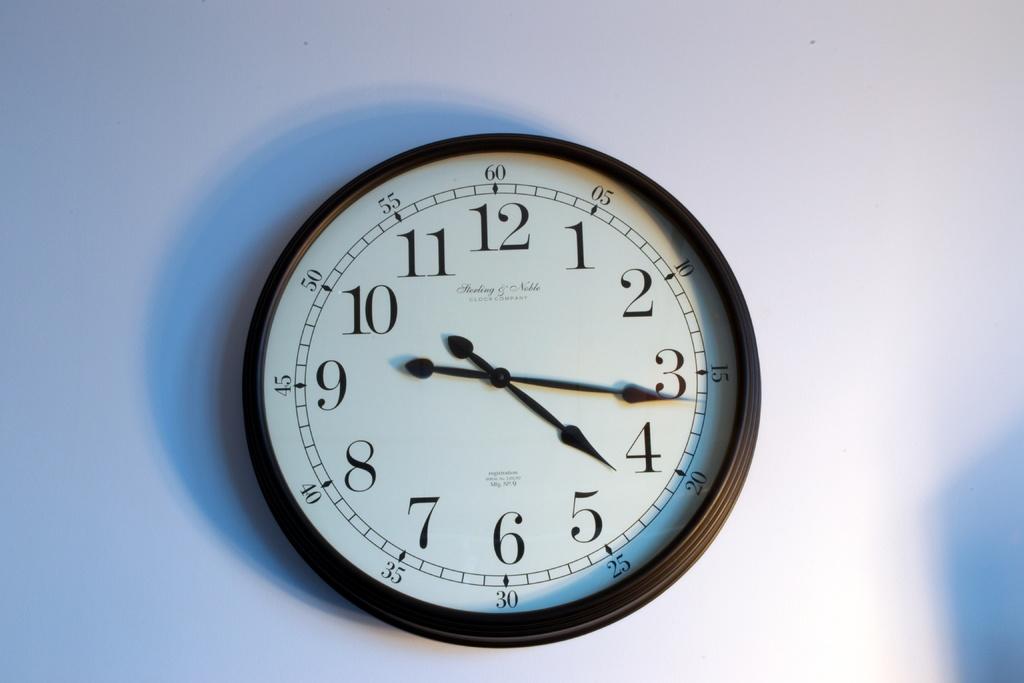What time is it?
Give a very brief answer. 4:16. 